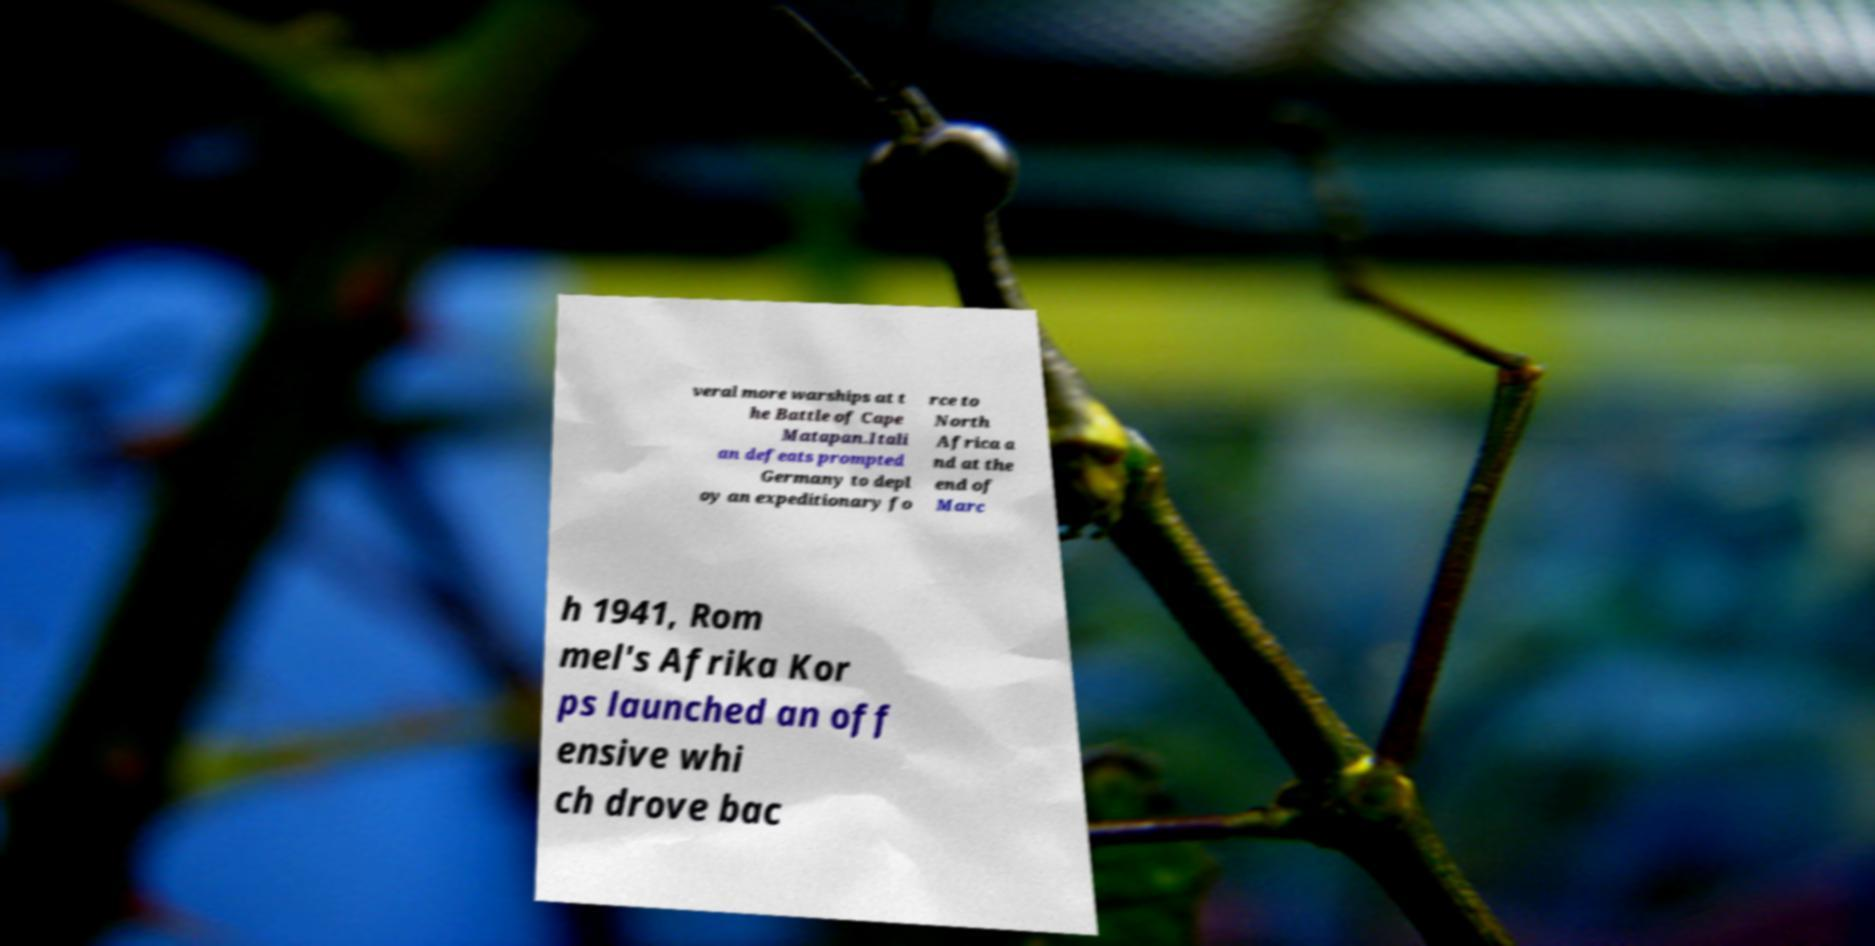Please read and relay the text visible in this image. What does it say? veral more warships at t he Battle of Cape Matapan.Itali an defeats prompted Germany to depl oy an expeditionary fo rce to North Africa a nd at the end of Marc h 1941, Rom mel's Afrika Kor ps launched an off ensive whi ch drove bac 